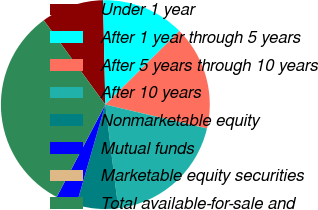<chart> <loc_0><loc_0><loc_500><loc_500><pie_chart><fcel>Under 1 year<fcel>After 1 year through 5 years<fcel>After 5 years through 10 years<fcel>After 10 years<fcel>Nonmarketable equity<fcel>Mutual funds<fcel>Marketable equity securities<fcel>Total available-for-sale and<nl><fcel>9.68%<fcel>12.9%<fcel>16.13%<fcel>19.35%<fcel>6.45%<fcel>3.23%<fcel>0.0%<fcel>32.26%<nl></chart> 